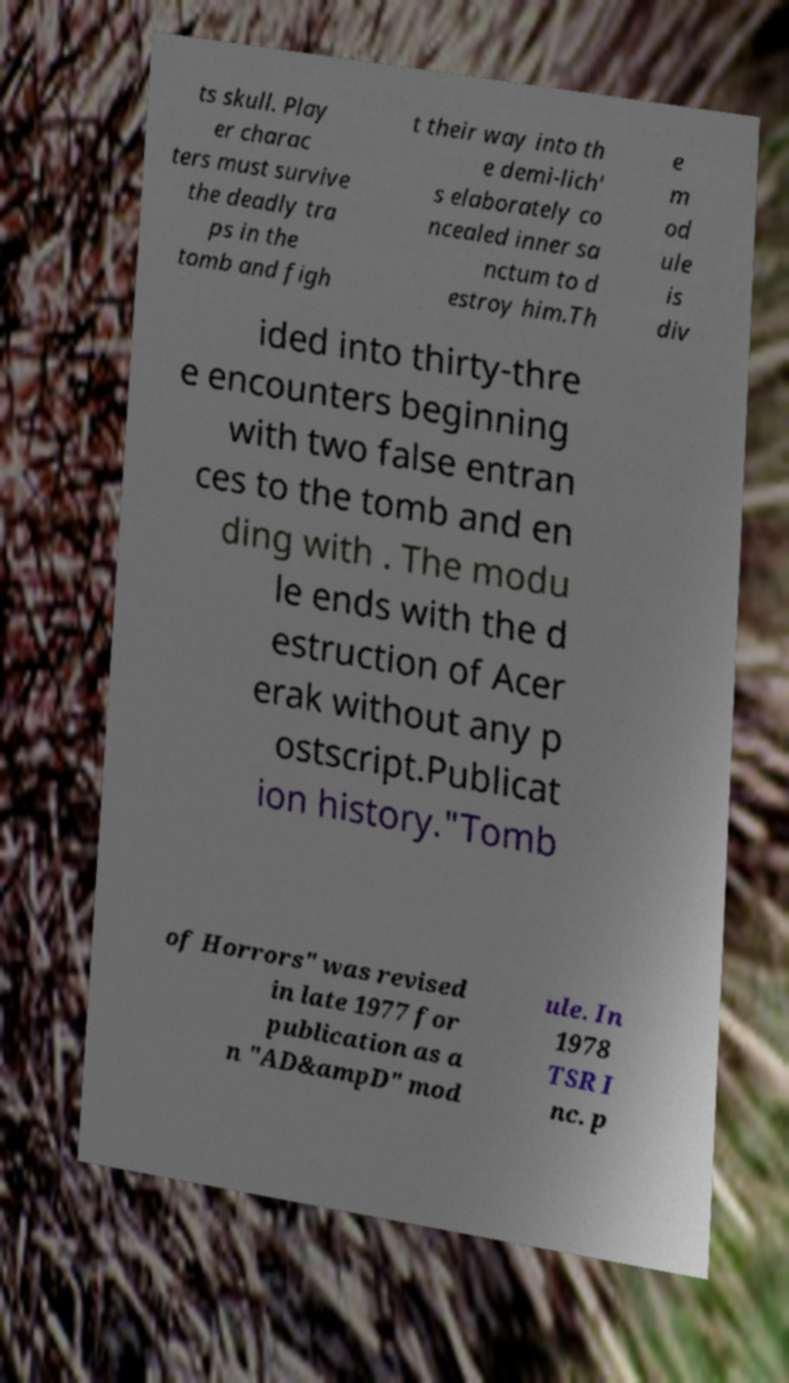What messages or text are displayed in this image? I need them in a readable, typed format. ts skull. Play er charac ters must survive the deadly tra ps in the tomb and figh t their way into th e demi-lich' s elaborately co ncealed inner sa nctum to d estroy him.Th e m od ule is div ided into thirty-thre e encounters beginning with two false entran ces to the tomb and en ding with . The modu le ends with the d estruction of Acer erak without any p ostscript.Publicat ion history."Tomb of Horrors" was revised in late 1977 for publication as a n "AD&ampD" mod ule. In 1978 TSR I nc. p 